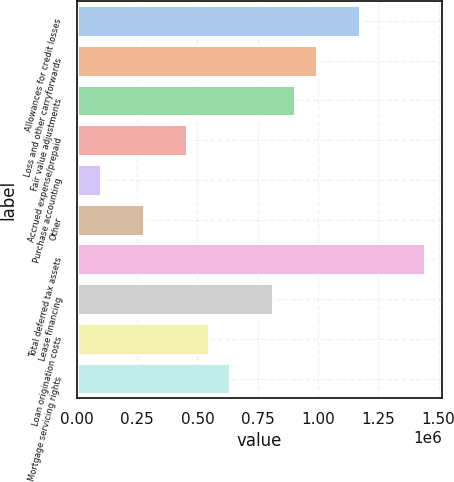Convert chart. <chart><loc_0><loc_0><loc_500><loc_500><bar_chart><fcel>Allowances for credit losses<fcel>Loss and other carryforwards<fcel>Fair value adjustments<fcel>Accrued expense/prepaid<fcel>Purchase accounting<fcel>Other<fcel>Total deferred tax assets<fcel>Lease financing<fcel>Loan origination costs<fcel>Mortgage servicing rights<nl><fcel>1.17331e+06<fcel>994095<fcel>904489<fcel>456459<fcel>98035<fcel>277247<fcel>1.44212e+06<fcel>814883<fcel>546065<fcel>635671<nl></chart> 